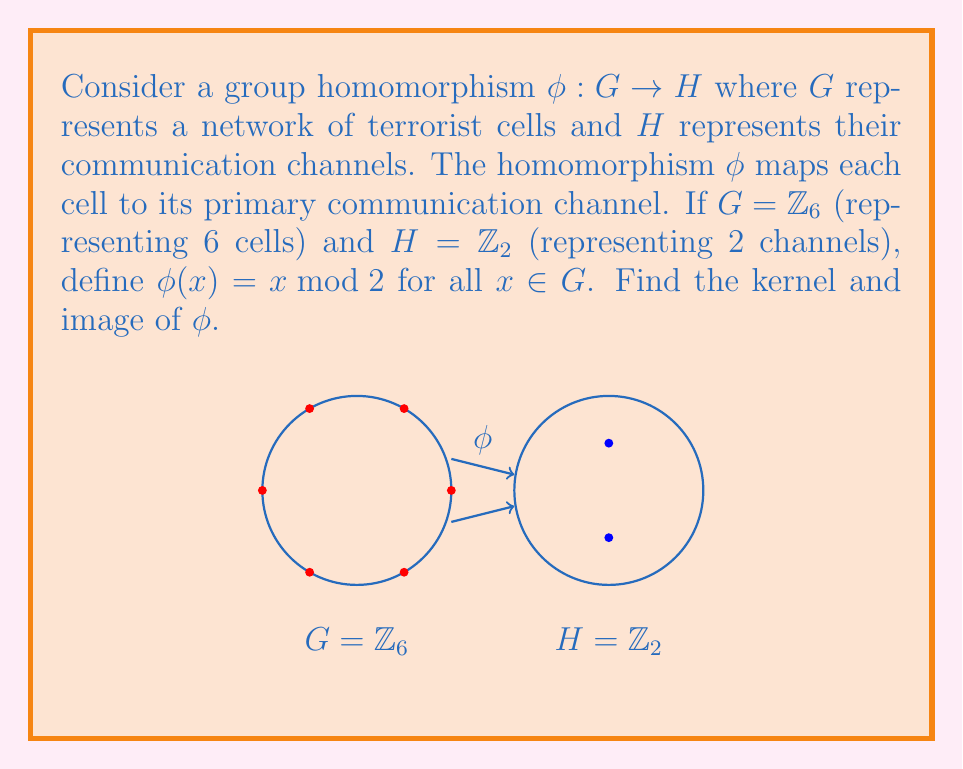Teach me how to tackle this problem. To find the kernel and image of $\phi$, we need to follow these steps:

1) Recall that the kernel of a homomorphism $\phi: G \to H$ is defined as:
   $\ker(\phi) = \{g \in G : \phi(g) = e_H\}$, where $e_H$ is the identity element of $H$.

2) In $\mathbb{Z}_2$, the identity element is 0.

3) We need to find all elements $x \in \mathbb{Z}_6$ such that $\phi(x) = 0 \bmod 2$.

4) Let's compute $\phi(x)$ for all $x \in \mathbb{Z}_6$:
   $\phi(0) = 0 \bmod 2 = 0$
   $\phi(1) = 1 \bmod 2 = 1$
   $\phi(2) = 2 \bmod 2 = 0$
   $\phi(3) = 3 \bmod 2 = 1$
   $\phi(4) = 4 \bmod 2 = 0$
   $\phi(5) = 5 \bmod 2 = 1$

5) The elements that map to 0 are 0, 2, and 4. Therefore, $\ker(\phi) = \{0, 2, 4\}$.

6) The image of $\phi$ is the set of all elements in $H$ that are mapped to by some element in $G$.

7) From our calculations in step 4, we can see that $\phi$ maps to both 0 and 1 in $\mathbb{Z}_2$.

8) Therefore, $\text{Im}(\phi) = \{0, 1\} = \mathbb{Z}_2$.
Answer: $\ker(\phi) = \{0, 2, 4\}$, $\text{Im}(\phi) = \mathbb{Z}_2$ 